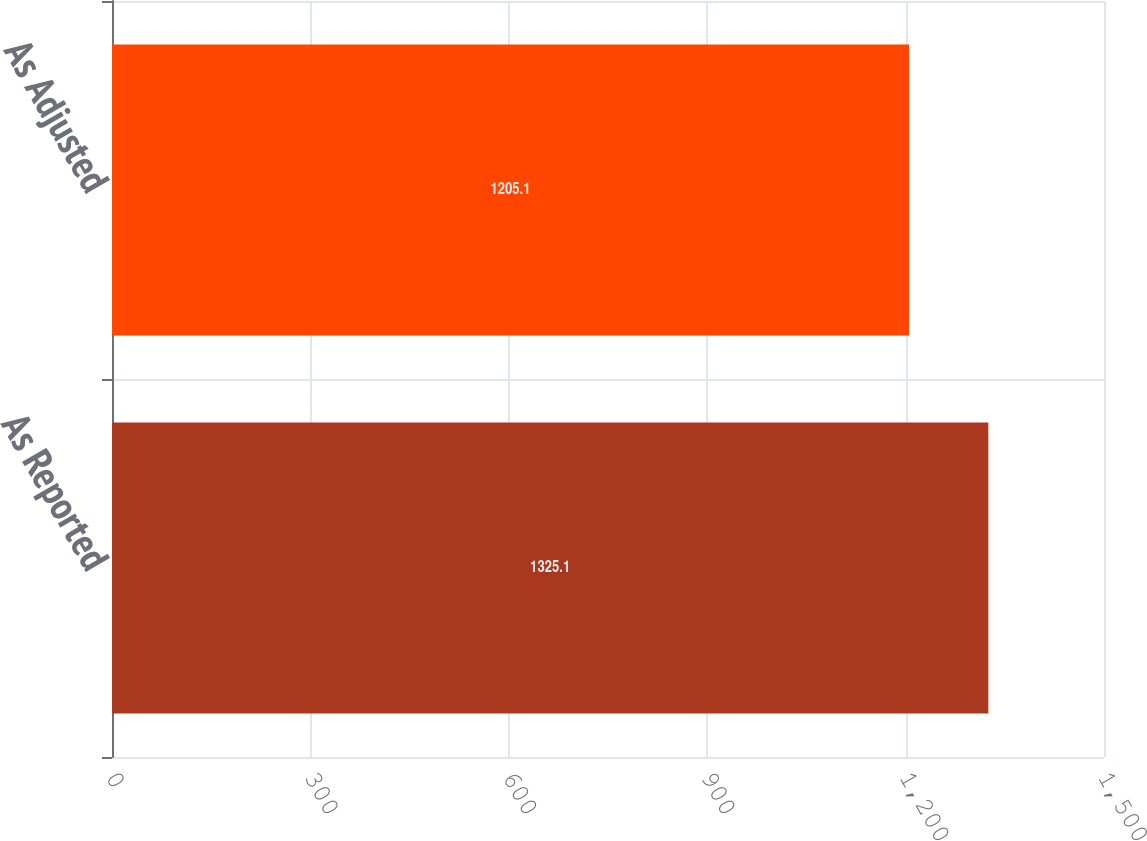<chart> <loc_0><loc_0><loc_500><loc_500><bar_chart><fcel>As Reported<fcel>As Adjusted<nl><fcel>1325.1<fcel>1205.1<nl></chart> 